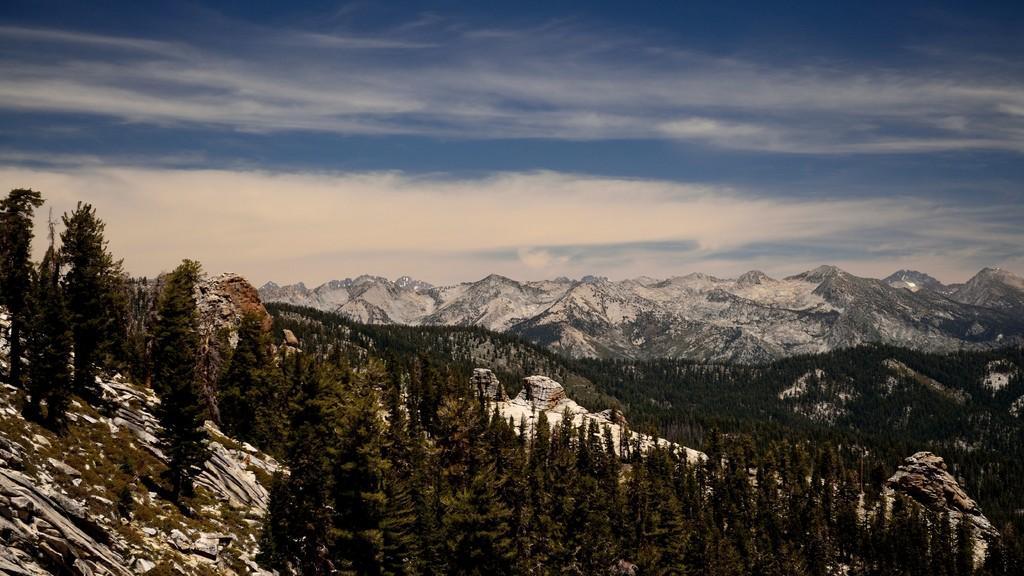Describe this image in one or two sentences. In this image I can see many trees and mountains. There is sky at the top. 